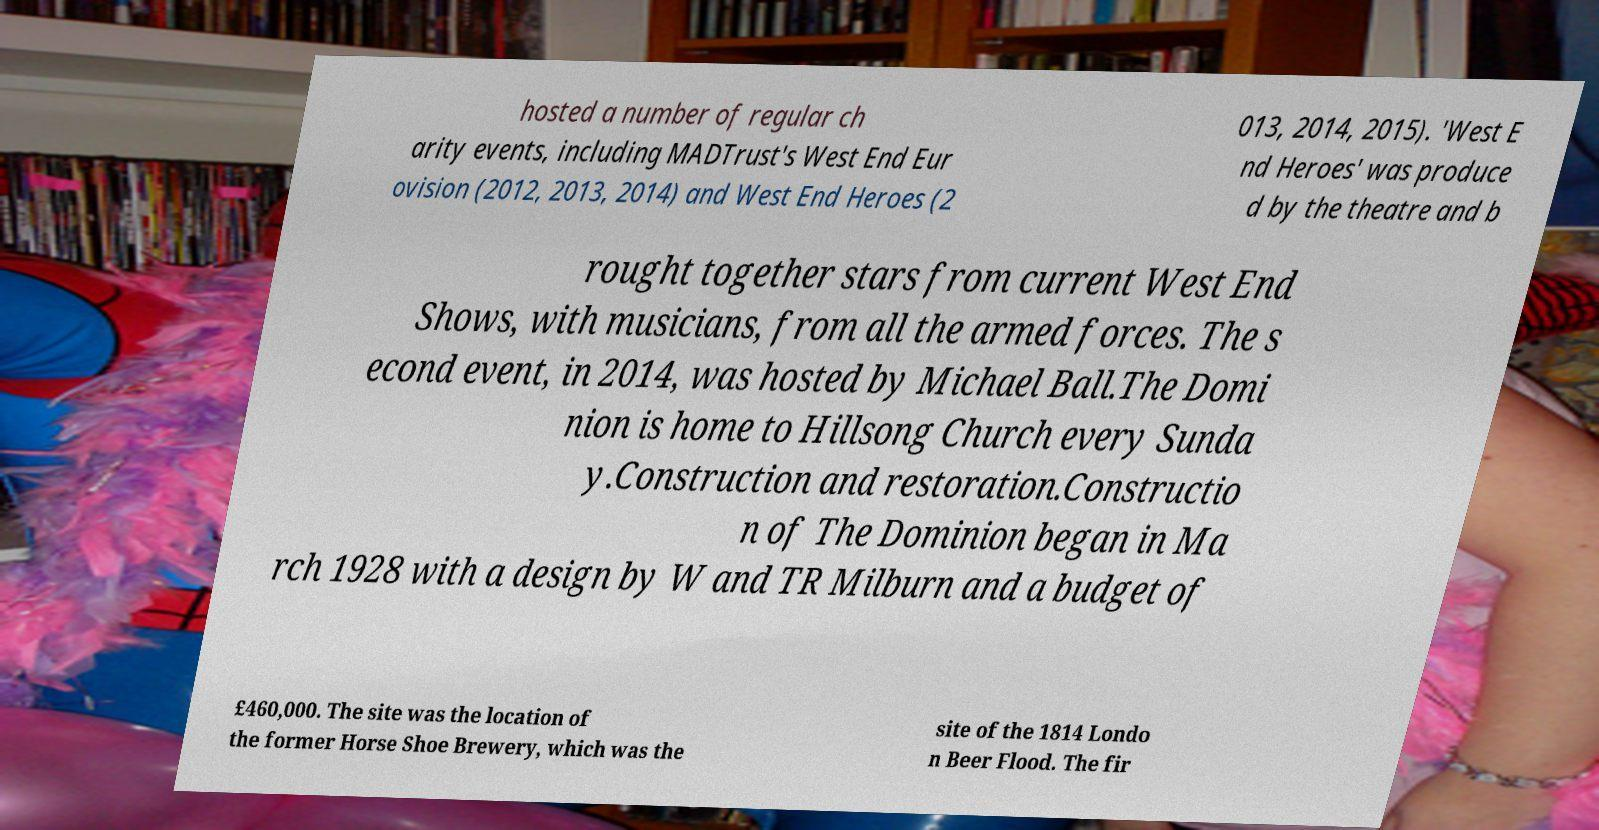Please read and relay the text visible in this image. What does it say? hosted a number of regular ch arity events, including MADTrust's West End Eur ovision (2012, 2013, 2014) and West End Heroes (2 013, 2014, 2015). 'West E nd Heroes' was produce d by the theatre and b rought together stars from current West End Shows, with musicians, from all the armed forces. The s econd event, in 2014, was hosted by Michael Ball.The Domi nion is home to Hillsong Church every Sunda y.Construction and restoration.Constructio n of The Dominion began in Ma rch 1928 with a design by W and TR Milburn and a budget of £460,000. The site was the location of the former Horse Shoe Brewery, which was the site of the 1814 Londo n Beer Flood. The fir 